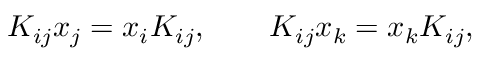Convert formula to latex. <formula><loc_0><loc_0><loc_500><loc_500>K _ { i j } x _ { j } = x _ { i } K _ { i j } , \quad K _ { i j } x _ { k } = x _ { k } K _ { i j } ,</formula> 